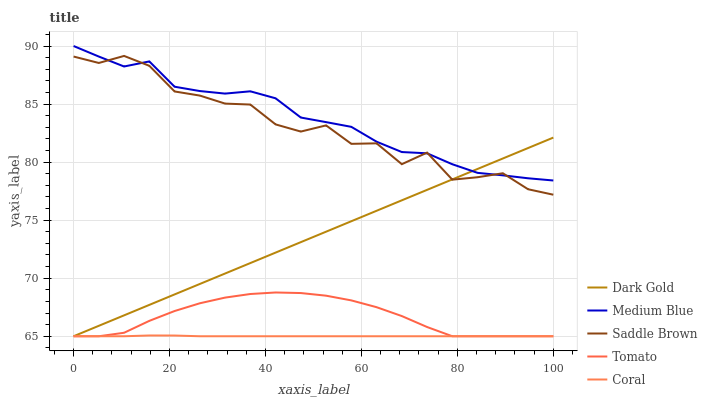Does Coral have the minimum area under the curve?
Answer yes or no. Yes. Does Medium Blue have the maximum area under the curve?
Answer yes or no. Yes. Does Medium Blue have the minimum area under the curve?
Answer yes or no. No. Does Coral have the maximum area under the curve?
Answer yes or no. No. Is Dark Gold the smoothest?
Answer yes or no. Yes. Is Saddle Brown the roughest?
Answer yes or no. Yes. Is Coral the smoothest?
Answer yes or no. No. Is Coral the roughest?
Answer yes or no. No. Does Tomato have the lowest value?
Answer yes or no. Yes. Does Medium Blue have the lowest value?
Answer yes or no. No. Does Medium Blue have the highest value?
Answer yes or no. Yes. Does Coral have the highest value?
Answer yes or no. No. Is Coral less than Saddle Brown?
Answer yes or no. Yes. Is Saddle Brown greater than Coral?
Answer yes or no. Yes. Does Tomato intersect Coral?
Answer yes or no. Yes. Is Tomato less than Coral?
Answer yes or no. No. Is Tomato greater than Coral?
Answer yes or no. No. Does Coral intersect Saddle Brown?
Answer yes or no. No. 